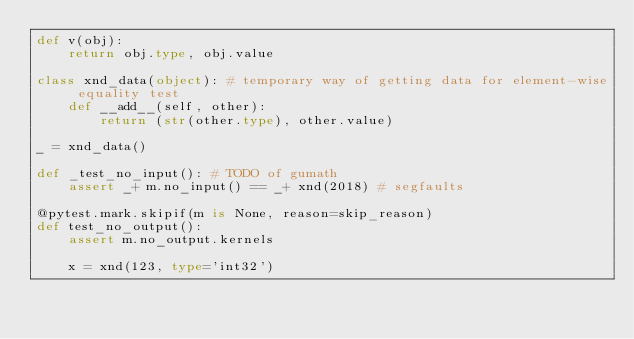Convert code to text. <code><loc_0><loc_0><loc_500><loc_500><_Python_>def v(obj):
    return obj.type, obj.value

class xnd_data(object): # temporary way of getting data for element-wise equality test
    def __add__(self, other):
        return (str(other.type), other.value)
    
_ = xnd_data()

def _test_no_input(): # TODO of gumath
    assert _+ m.no_input() == _+ xnd(2018) # segfaults

@pytest.mark.skipif(m is None, reason=skip_reason)
def test_no_output():
    assert m.no_output.kernels
    
    x = xnd(123, type='int32')</code> 